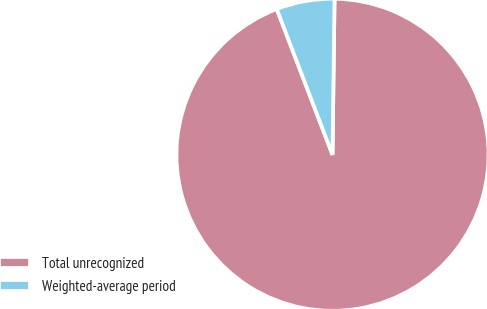<chart> <loc_0><loc_0><loc_500><loc_500><pie_chart><fcel>Total unrecognized<fcel>Weighted-average period<nl><fcel>93.98%<fcel>6.02%<nl></chart> 